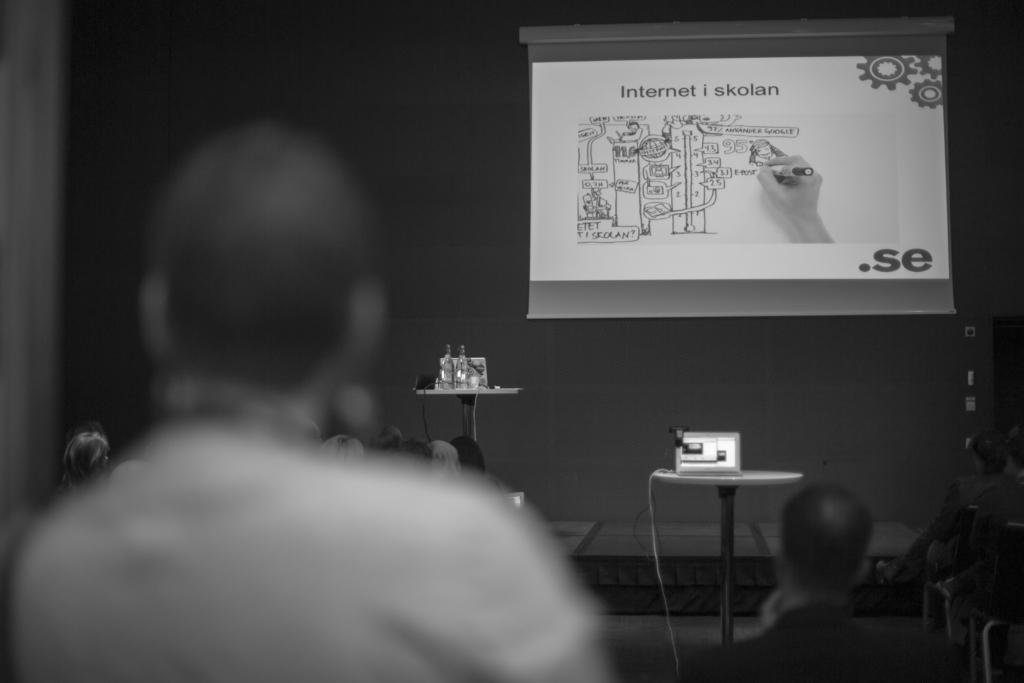Describe this image in one or two sentences. In this image i can see a person and in the background i can see few people, a wall, a projection screen with some projection and a projector. 